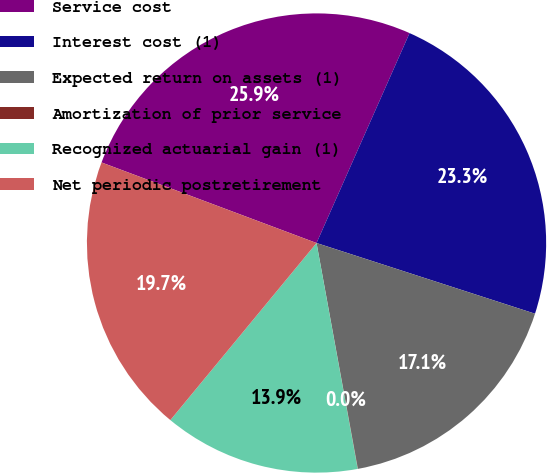<chart> <loc_0><loc_0><loc_500><loc_500><pie_chart><fcel>Service cost<fcel>Interest cost (1)<fcel>Expected return on assets (1)<fcel>Amortization of prior service<fcel>Recognized actuarial gain (1)<fcel>Net periodic postretirement<nl><fcel>25.93%<fcel>23.34%<fcel>17.13%<fcel>0.02%<fcel>13.85%<fcel>19.72%<nl></chart> 